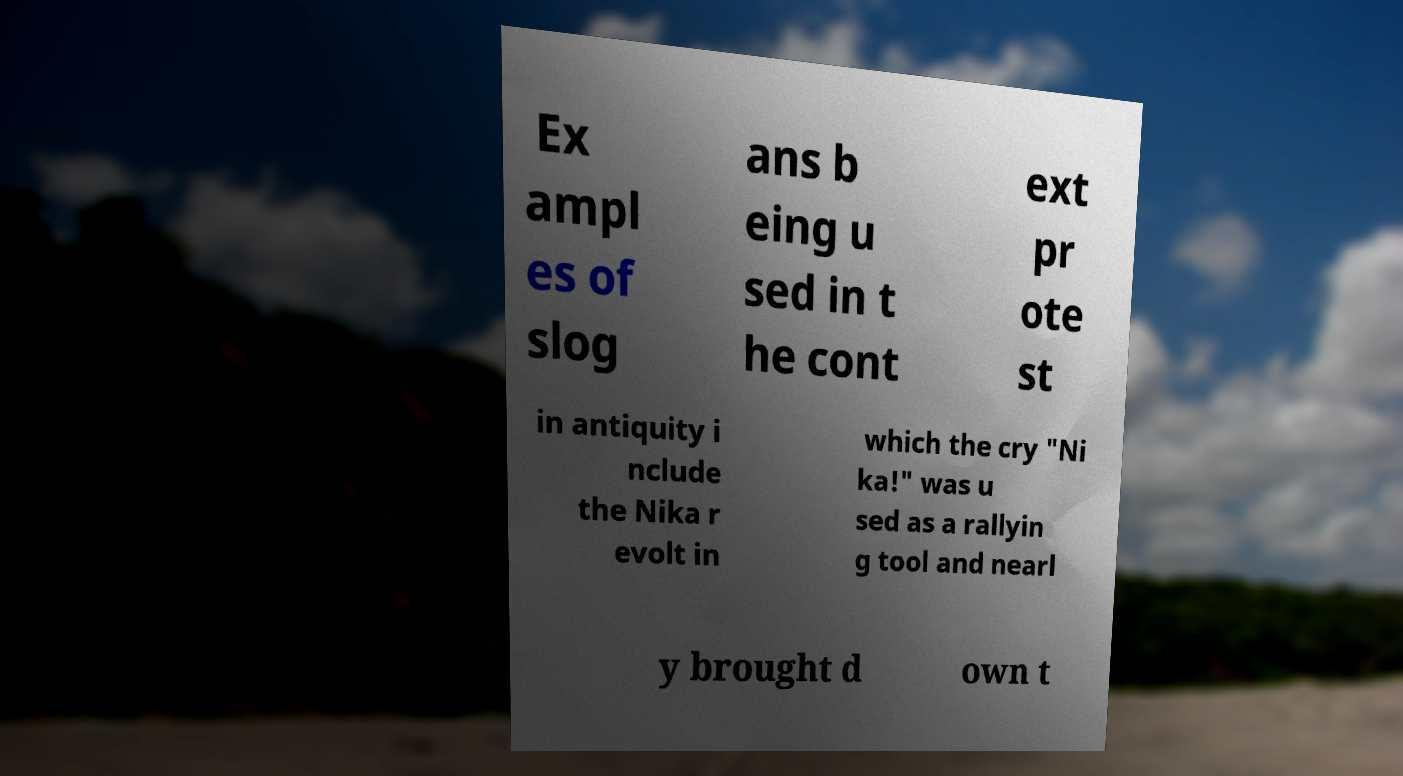Can you read and provide the text displayed in the image?This photo seems to have some interesting text. Can you extract and type it out for me? Ex ampl es of slog ans b eing u sed in t he cont ext pr ote st in antiquity i nclude the Nika r evolt in which the cry "Ni ka!" was u sed as a rallyin g tool and nearl y brought d own t 